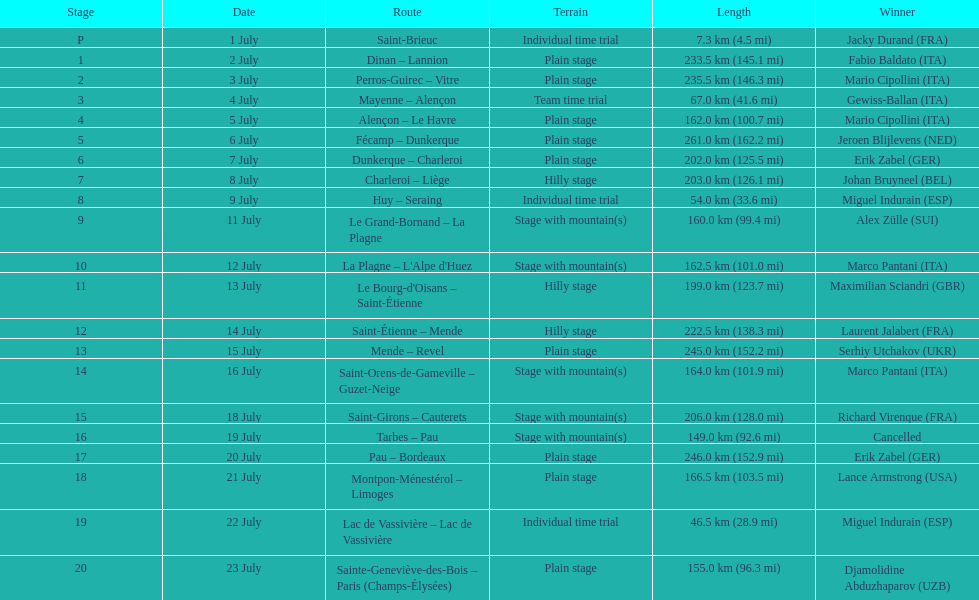After lance armstrong, who led next in the 1995 tour de france? Miguel Indurain. 